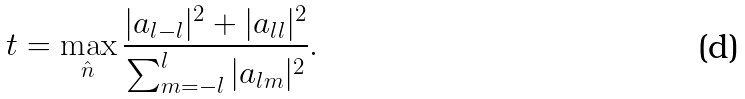<formula> <loc_0><loc_0><loc_500><loc_500>t = \max _ { \hat { n } } \frac { | a _ { l - l } | ^ { 2 } + | a _ { l l } | ^ { 2 } } { \sum _ { m = - l } ^ { l } | a _ { l m } | ^ { 2 } } .</formula> 